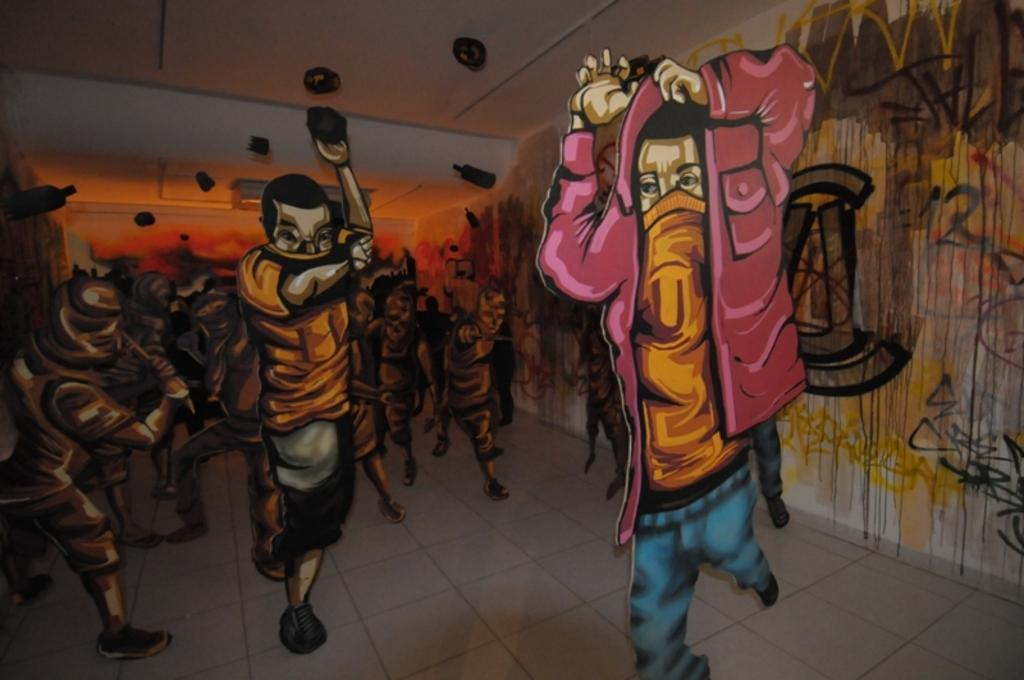What type of images are displayed on the posters in the image? There are posters of animated characters in the image. What can be seen on the walls in the background of the image? There are paintings on the walls in the background. What part of the room is visible at the top of the image? There is a ceiling visible at the top of the image. Where is the library located in the image? There is no library present in the image. Who is the partner of the person in the image? There is no person or partner present in the image; it only features posters, paintings, and a ceiling. 